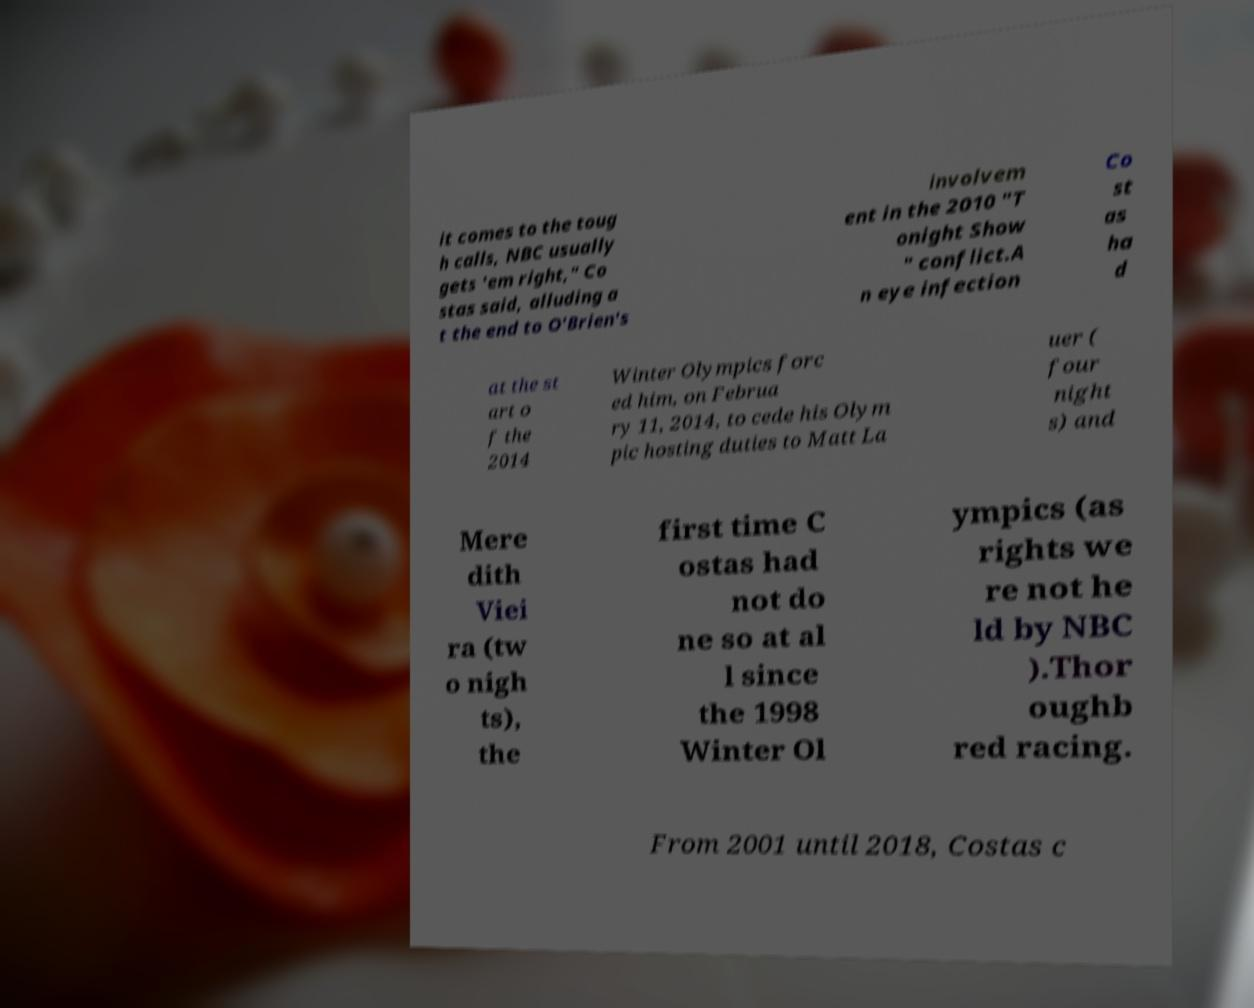What messages or text are displayed in this image? I need them in a readable, typed format. it comes to the toug h calls, NBC usually gets 'em right," Co stas said, alluding a t the end to O'Brien's involvem ent in the 2010 "T onight Show " conflict.A n eye infection Co st as ha d at the st art o f the 2014 Winter Olympics forc ed him, on Februa ry 11, 2014, to cede his Olym pic hosting duties to Matt La uer ( four night s) and Mere dith Viei ra (tw o nigh ts), the first time C ostas had not do ne so at al l since the 1998 Winter Ol ympics (as rights we re not he ld by NBC ).Thor oughb red racing. From 2001 until 2018, Costas c 